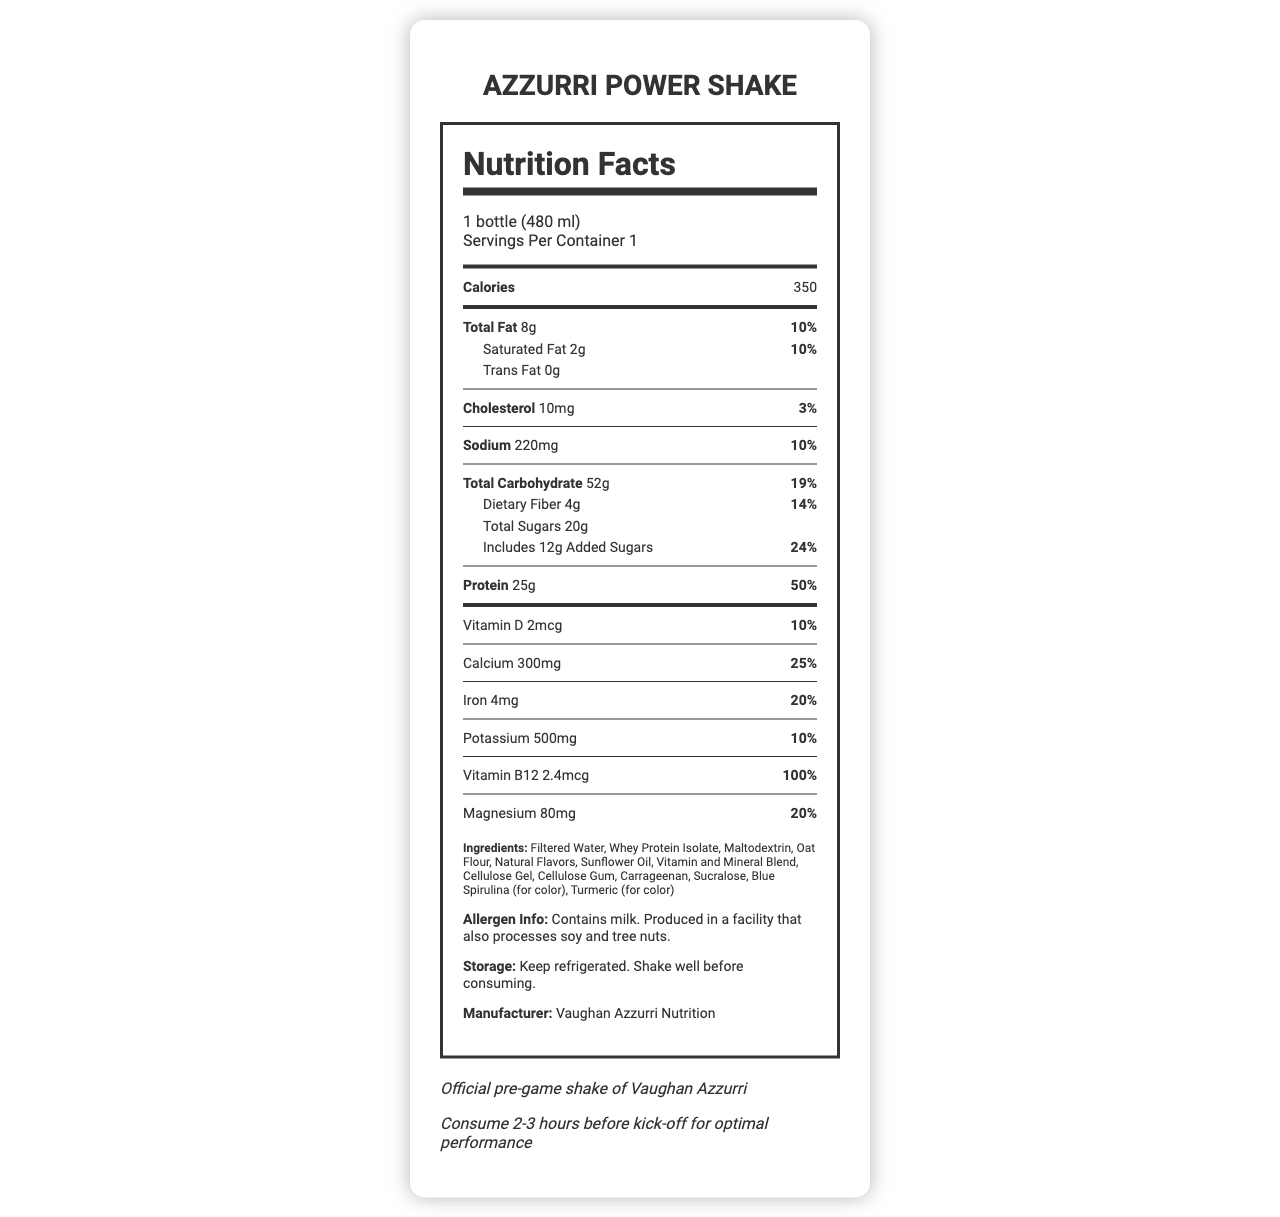What is the serving size of Azzurri Power Shake? The serving size is listed at the top of the Nutrition Facts as "1 bottle (480 ml)".
Answer: 1 bottle (480 ml) How many calories are in one serving of Azzurri Power Shake? The calories per serving are mentioned right below the serving size information as "Calories 350".
Answer: 350 What percentage of the daily value is provided by the protein content in the shake? Under the nutrient details, protein is listed with an amount of 25g and a daily value of 50%.
Answer: 50% Does this shake contain any trans fat? The document explicitly states "Trans Fat 0g" under the total fat section.
Answer: No How much dietary fiber does Azzurri Power Shake provide? The amount of dietary fiber is provided in the total carbohydrate section as "Dietary Fiber 4g".
Answer: 4g What is the primary color of the Vaughan Azzurri team? A. Red B. Royal Blue C. Green The team colors section of the document lists the primary color as "Royal Blue".
Answer: B How much sodium is in the Azzurri Power Shake? A. 200mg B. 220mg C. 250mg The sodium content is listed as "Sodium 220mg".
Answer: B Does this product contain any soy or tree nuts? The allergen info specifies that the product is made in a facility that processes soy and tree nuts.
Answer: Not directly, but it is produced in a facility that processes soy and tree nuts True or False: The storage instructions recommend to refrigerate the shake. The storage instructions clearly state "Keep refrigerated".
Answer: True Summarize the main information provided in the document. The document provides detailed nutritional information and highlights the product's association with the Vaughan Azzurri team, including their team colors and match day tips.
Answer: The document describes the nutrition facts, ingredients, storage instructions, and additional information for the Azzurri Power Shake, an official pre-game meal replacement shake for the Vaughan Azzurri team. The shake provides 350 calories per 480 ml bottle and contains proteins, vitamins, and minerals beneficial for pre-game consumption. What steps should be taken before consuming the shake on a match day? The match day tip in the additional info section suggests consuming the shake 2-3 hours before kick-off.
Answer: Consume 2-3 hours before kick-off for optimal performance What type of protein is used in the Azzurri Power Shake? Among the ingredients, "Whey Protein Isolate" is listed, indicating it is the type of protein used.
Answer: Whey protein isolate How much Vitamin B12 does this shake contain? The Vitamin B12 content is specified in the document as "Vitamin B12 2.4mcg".
Answer: 2.4mcg What is the daily value percentage of calcium in the shake? The amount of calcium and its daily value percentage is listed as "Calcium 300mg 25%".
Answer: 25% Does the document specify the flavor of the shake? The document lists "Natural Flavors" without specifying the exact flavor of the shake.
Answer: Not enough information 